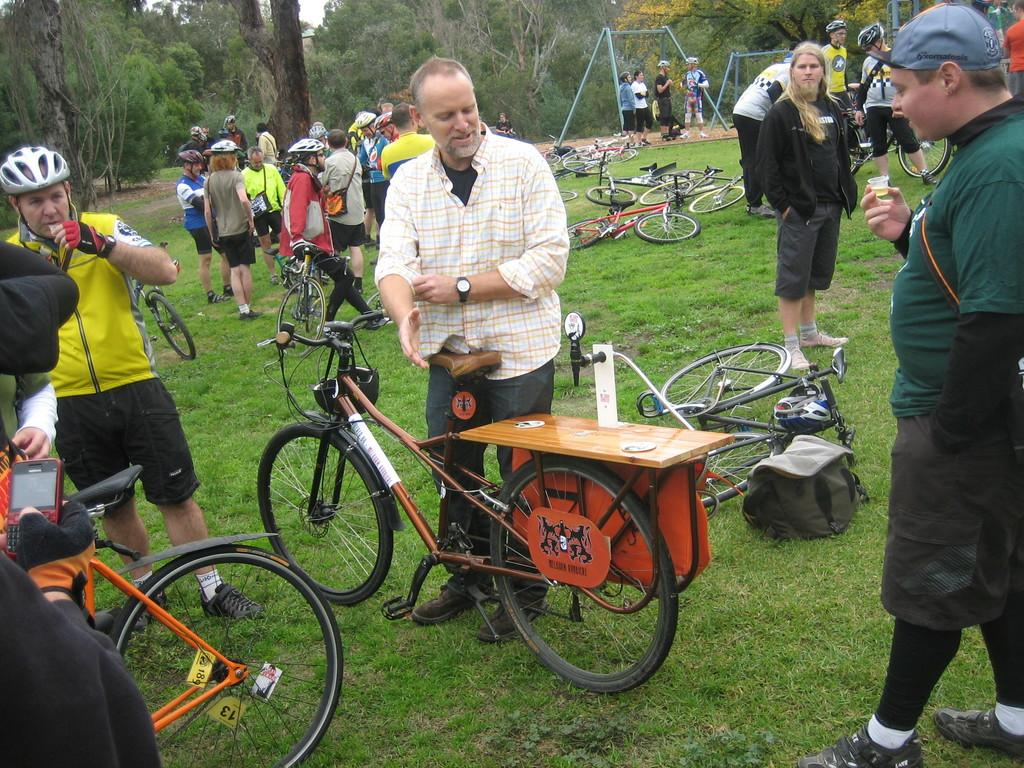How many people can be seen in the image? There are many people in the image. What objects are the people using in the image? There are bicycles in the image. What type of terrain is visible in the image? The land in the image is grassy. What type of vegetation is present at the top of the image? Trees are present at the top of the image. What type of drug is the mother using to make the people smile in the image? There is no mention of a mother, drug, or smiling people in the image. The image features many people and bicycles on a grassy terrain with trees at the top. 